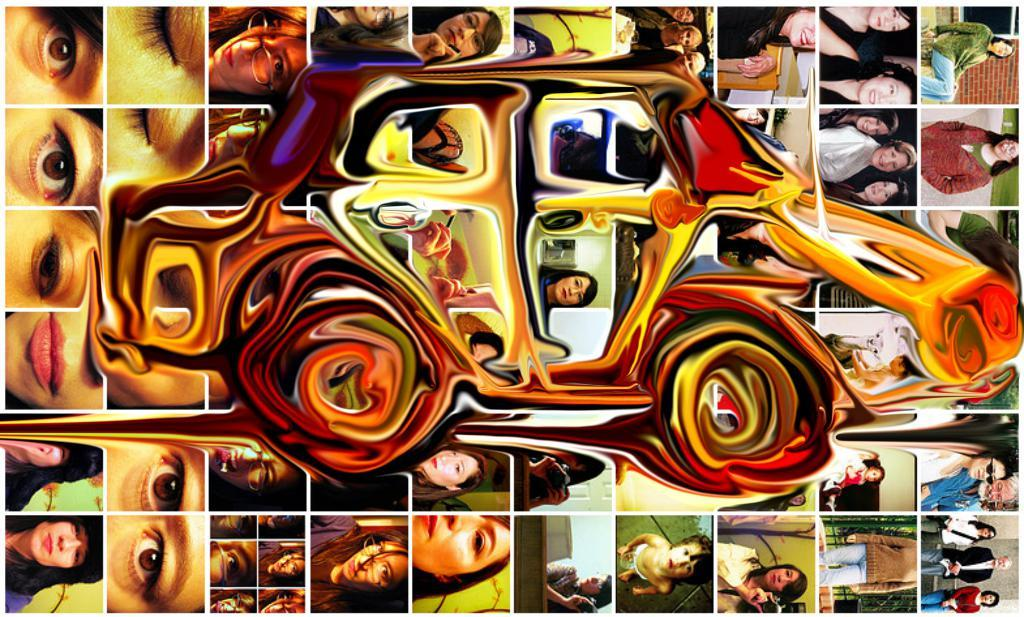What is the main subject of the image? The main subject of the image is an edited image of a car. What can be seen in the background of the image? There is a collage picture in the background. What is included in the collage picture? The collage picture includes persons. Where is the crown placed in the image? There is no crown present in the image. What type of surprise can be seen in the image? There is no surprise depicted in the image. 